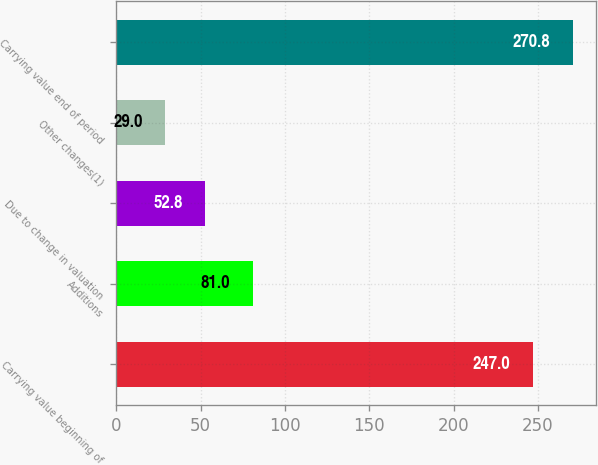<chart> <loc_0><loc_0><loc_500><loc_500><bar_chart><fcel>Carrying value beginning of<fcel>Additions<fcel>Due to change in valuation<fcel>Other changes(1)<fcel>Carrying value end of period<nl><fcel>247<fcel>81<fcel>52.8<fcel>29<fcel>270.8<nl></chart> 